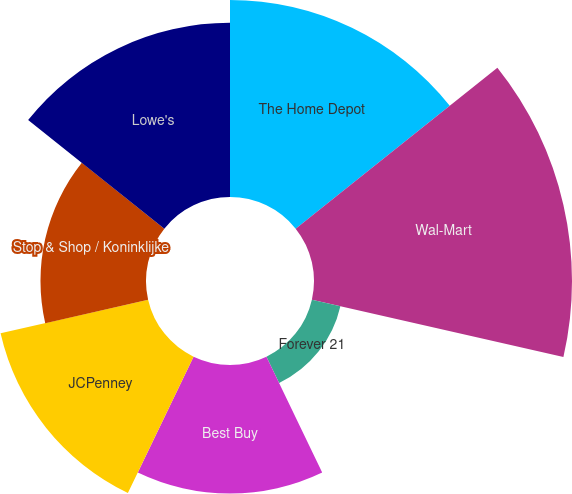<chart> <loc_0><loc_0><loc_500><loc_500><pie_chart><fcel>The Home Depot<fcel>Wal-Mart<fcel>Forever 21<fcel>Best Buy<fcel>JCPenney<fcel>Stop & Shop / Koninklijke<fcel>Lowe's<nl><fcel>18.88%<fcel>24.72%<fcel>2.8%<fcel>12.31%<fcel>14.5%<fcel>10.11%<fcel>16.69%<nl></chart> 